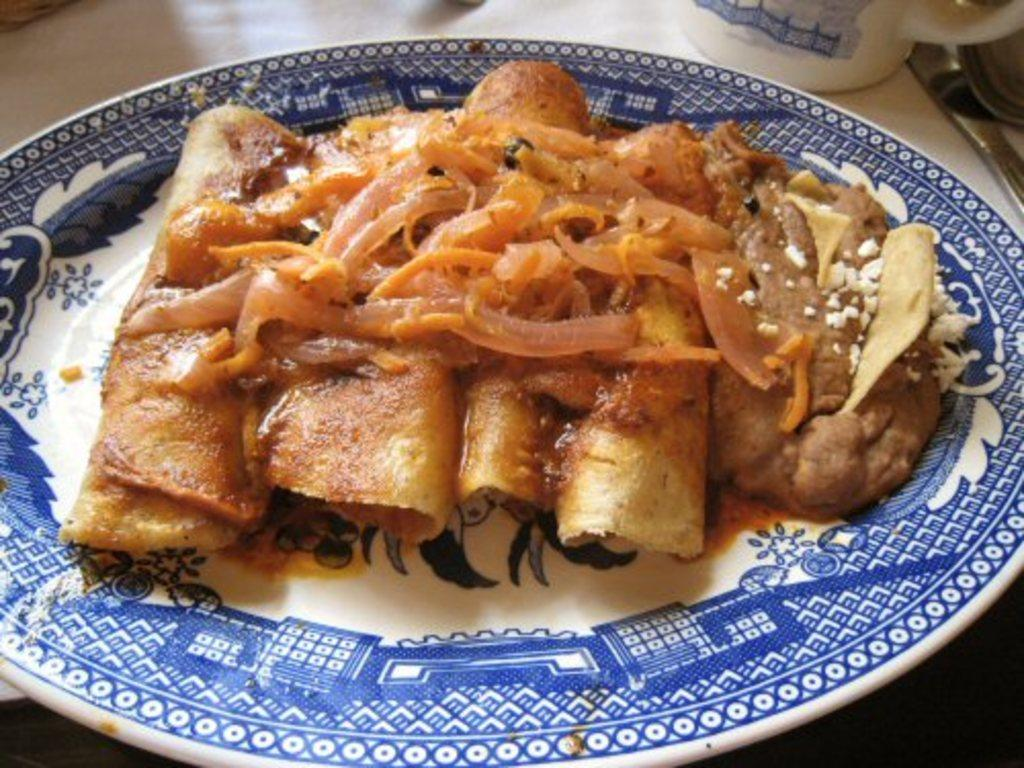What is the main subject of the image? The main subject of the image is food. How is the food presented in the image? The food is on a white and blue color plate. What is the plate placed on in the image? The plate is placed on a wooden table top. What other item can be seen near the plate in the image? There is a teacup beside the plate. What type of wound can be seen on the food in the image? There is no wound present on the food in the image. What reason might the person have for placing the food on the plate in the image? The reason for placing the food on the plate cannot be determined from the image alone. 